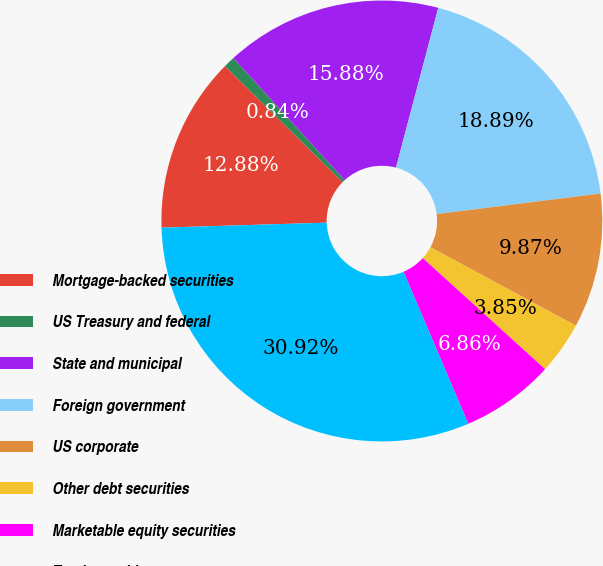Convert chart. <chart><loc_0><loc_0><loc_500><loc_500><pie_chart><fcel>Mortgage-backed securities<fcel>US Treasury and federal<fcel>State and municipal<fcel>Foreign government<fcel>US corporate<fcel>Other debt securities<fcel>Marketable equity securities<fcel>Total securities<nl><fcel>12.88%<fcel>0.84%<fcel>15.88%<fcel>18.89%<fcel>9.87%<fcel>3.85%<fcel>6.86%<fcel>30.92%<nl></chart> 